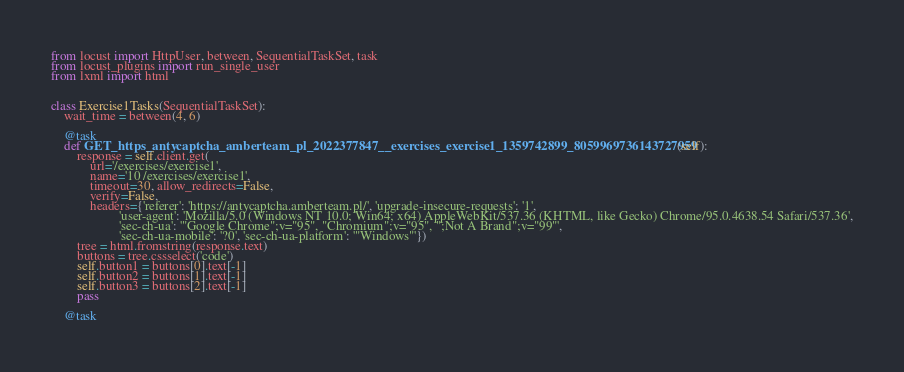Convert code to text. <code><loc_0><loc_0><loc_500><loc_500><_Python_>from locust import HttpUser, between, SequentialTaskSet, task
from locust_plugins import run_single_user
from lxml import html


class Exercise1Tasks(SequentialTaskSet):
    wait_time = between(4, 6)

    @task
    def GET_https_antycaptcha_amberteam_pl_2022377847__exercises_exercise1_1359742899_8059969736143727959(self):
        response = self.client.get(
            url='/exercises/exercise1',
            name='10 /exercises/exercise1',
            timeout=30, allow_redirects=False,
            verify=False,
            headers={'referer': 'https://antycaptcha.amberteam.pl/', 'upgrade-insecure-requests': '1',
                     'user-agent': 'Mozilla/5.0 (Windows NT 10.0; Win64; x64) AppleWebKit/537.36 (KHTML, like Gecko) Chrome/95.0.4638.54 Safari/537.36',
                     'sec-ch-ua': '"Google Chrome";v="95", "Chromium";v="95", ";Not A Brand";v="99"',
                     'sec-ch-ua-mobile': '?0', 'sec-ch-ua-platform': '"Windows"'})
        tree = html.fromstring(response.text)
        buttons = tree.cssselect('code')
        self.button1 = buttons[0].text[-1]
        self.button2 = buttons[1].text[-1]
        self.button3 = buttons[2].text[-1]
        pass

    @task</code> 